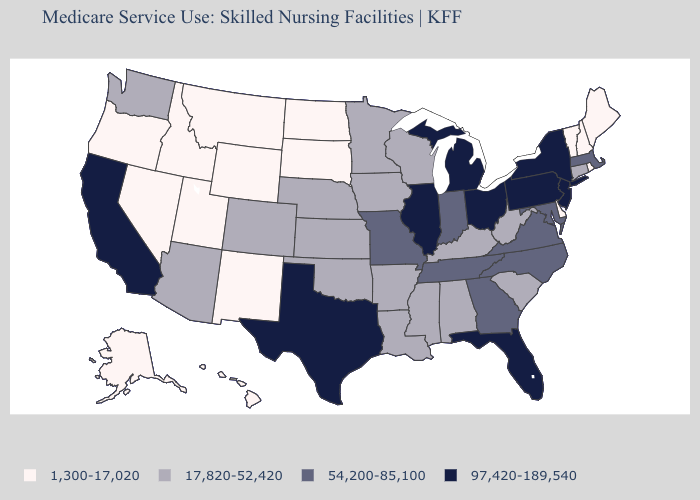What is the lowest value in states that border Indiana?
Be succinct. 17,820-52,420. What is the lowest value in the USA?
Quick response, please. 1,300-17,020. Name the states that have a value in the range 17,820-52,420?
Short answer required. Alabama, Arizona, Arkansas, Colorado, Connecticut, Iowa, Kansas, Kentucky, Louisiana, Minnesota, Mississippi, Nebraska, Oklahoma, South Carolina, Washington, West Virginia, Wisconsin. What is the value of Kansas?
Keep it brief. 17,820-52,420. Is the legend a continuous bar?
Short answer required. No. Does South Carolina have the same value as New York?
Short answer required. No. Name the states that have a value in the range 17,820-52,420?
Be succinct. Alabama, Arizona, Arkansas, Colorado, Connecticut, Iowa, Kansas, Kentucky, Louisiana, Minnesota, Mississippi, Nebraska, Oklahoma, South Carolina, Washington, West Virginia, Wisconsin. Does Nevada have the lowest value in the USA?
Concise answer only. Yes. Does Indiana have a higher value than Alaska?
Keep it brief. Yes. Among the states that border North Dakota , does Minnesota have the highest value?
Short answer required. Yes. Name the states that have a value in the range 97,420-189,540?
Give a very brief answer. California, Florida, Illinois, Michigan, New Jersey, New York, Ohio, Pennsylvania, Texas. What is the value of Nebraska?
Concise answer only. 17,820-52,420. Name the states that have a value in the range 97,420-189,540?
Keep it brief. California, Florida, Illinois, Michigan, New Jersey, New York, Ohio, Pennsylvania, Texas. Does Montana have the lowest value in the West?
Give a very brief answer. Yes. Among the states that border Rhode Island , which have the lowest value?
Write a very short answer. Connecticut. 